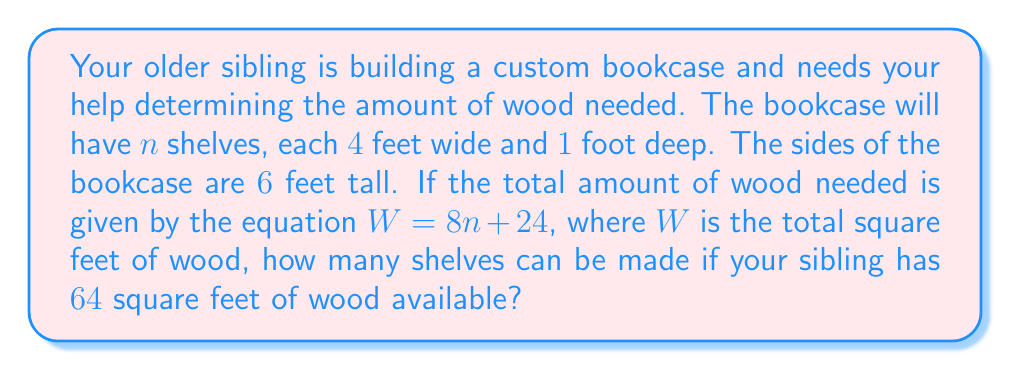Give your solution to this math problem. Let's approach this step-by-step:

1) We're given the equation: $W = 8n + 24$, where
   - $W$ is the total square feet of wood
   - $n$ is the number of shelves

2) We know that your sibling has 64 square feet of wood available, so we can substitute this for $W$:

   $64 = 8n + 24$

3) To solve for $n$, we first subtract 24 from both sides:

   $64 - 24 = 8n + 24 - 24$
   $40 = 8n$

4) Now, we divide both sides by 8:

   $\frac{40}{8} = \frac{8n}{8}$
   $5 = n$

5) Therefore, $n = 5$, meaning your sibling can make 5 shelves with the available wood.

To verify:
$W = 8n + 24$
$W = 8(5) + 24$
$W = 40 + 24 = 64$

This confirms that 5 shelves will indeed use all 64 square feet of available wood.
Answer: 5 shelves 